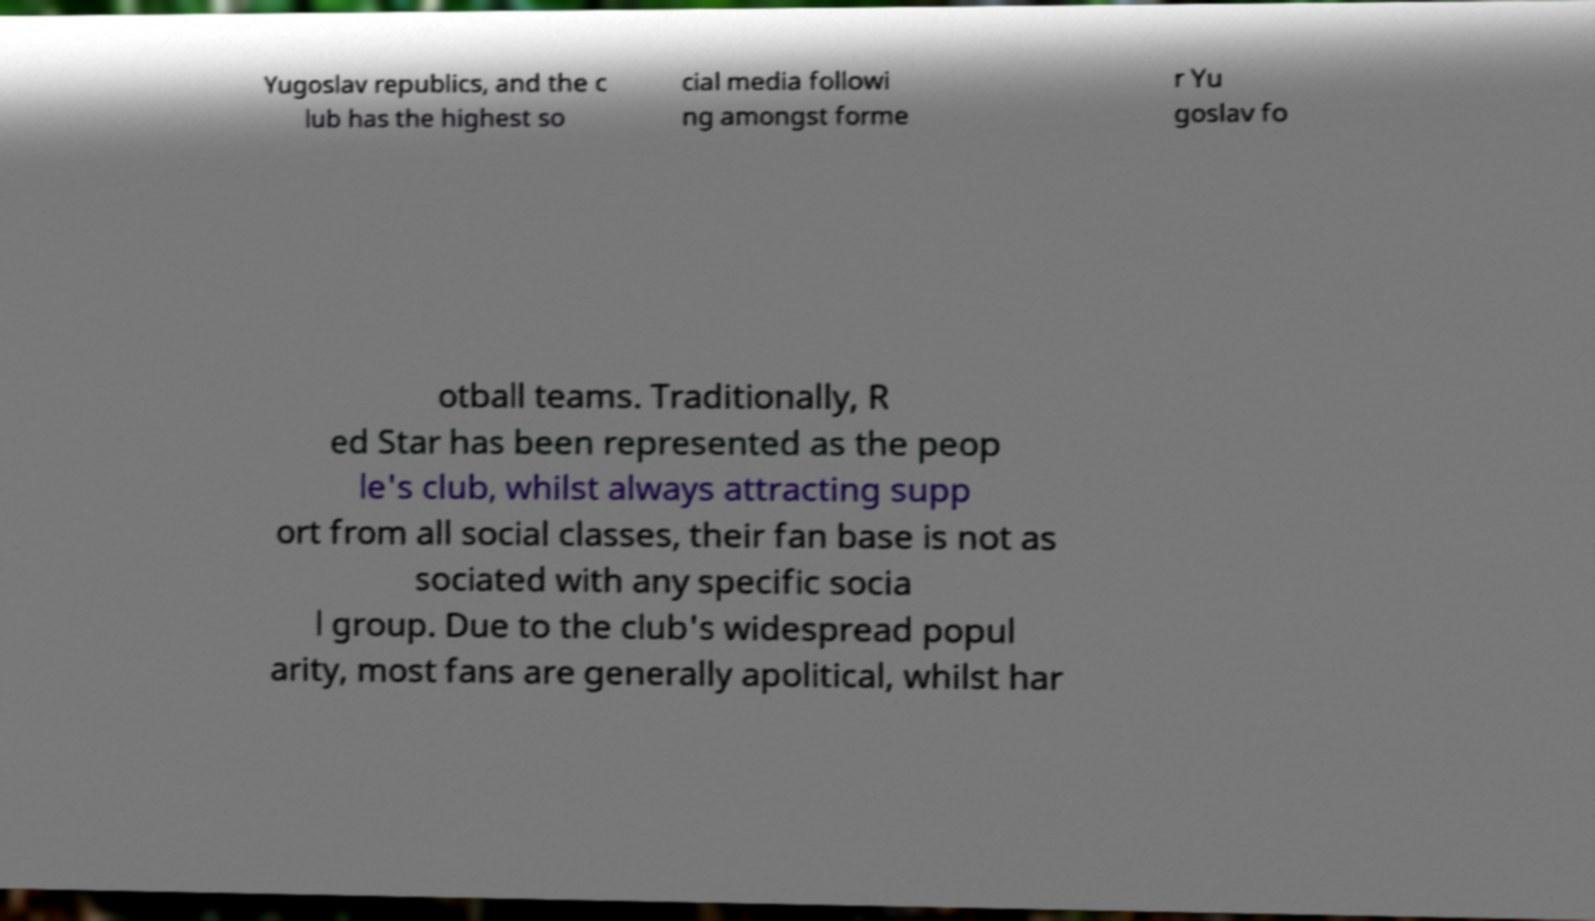For documentation purposes, I need the text within this image transcribed. Could you provide that? Yugoslav republics, and the c lub has the highest so cial media followi ng amongst forme r Yu goslav fo otball teams. Traditionally, R ed Star has been represented as the peop le's club, whilst always attracting supp ort from all social classes, their fan base is not as sociated with any specific socia l group. Due to the club's widespread popul arity, most fans are generally apolitical, whilst har 